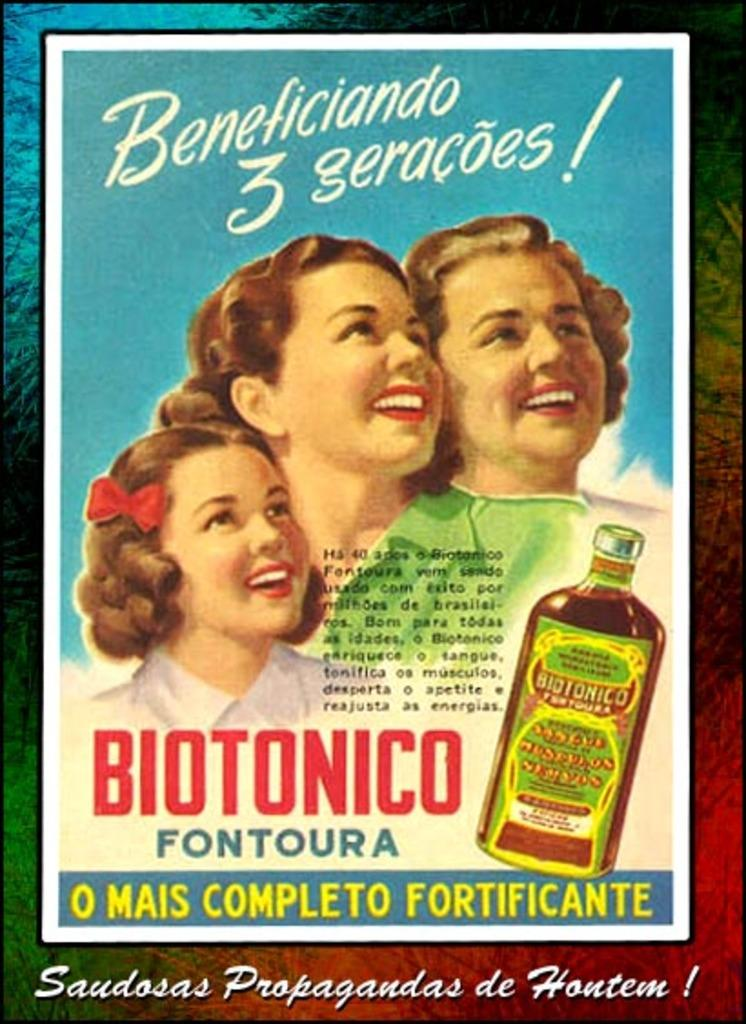<image>
Write a terse but informative summary of the picture. An advertisement for Biotonico Fontoura features three women. 